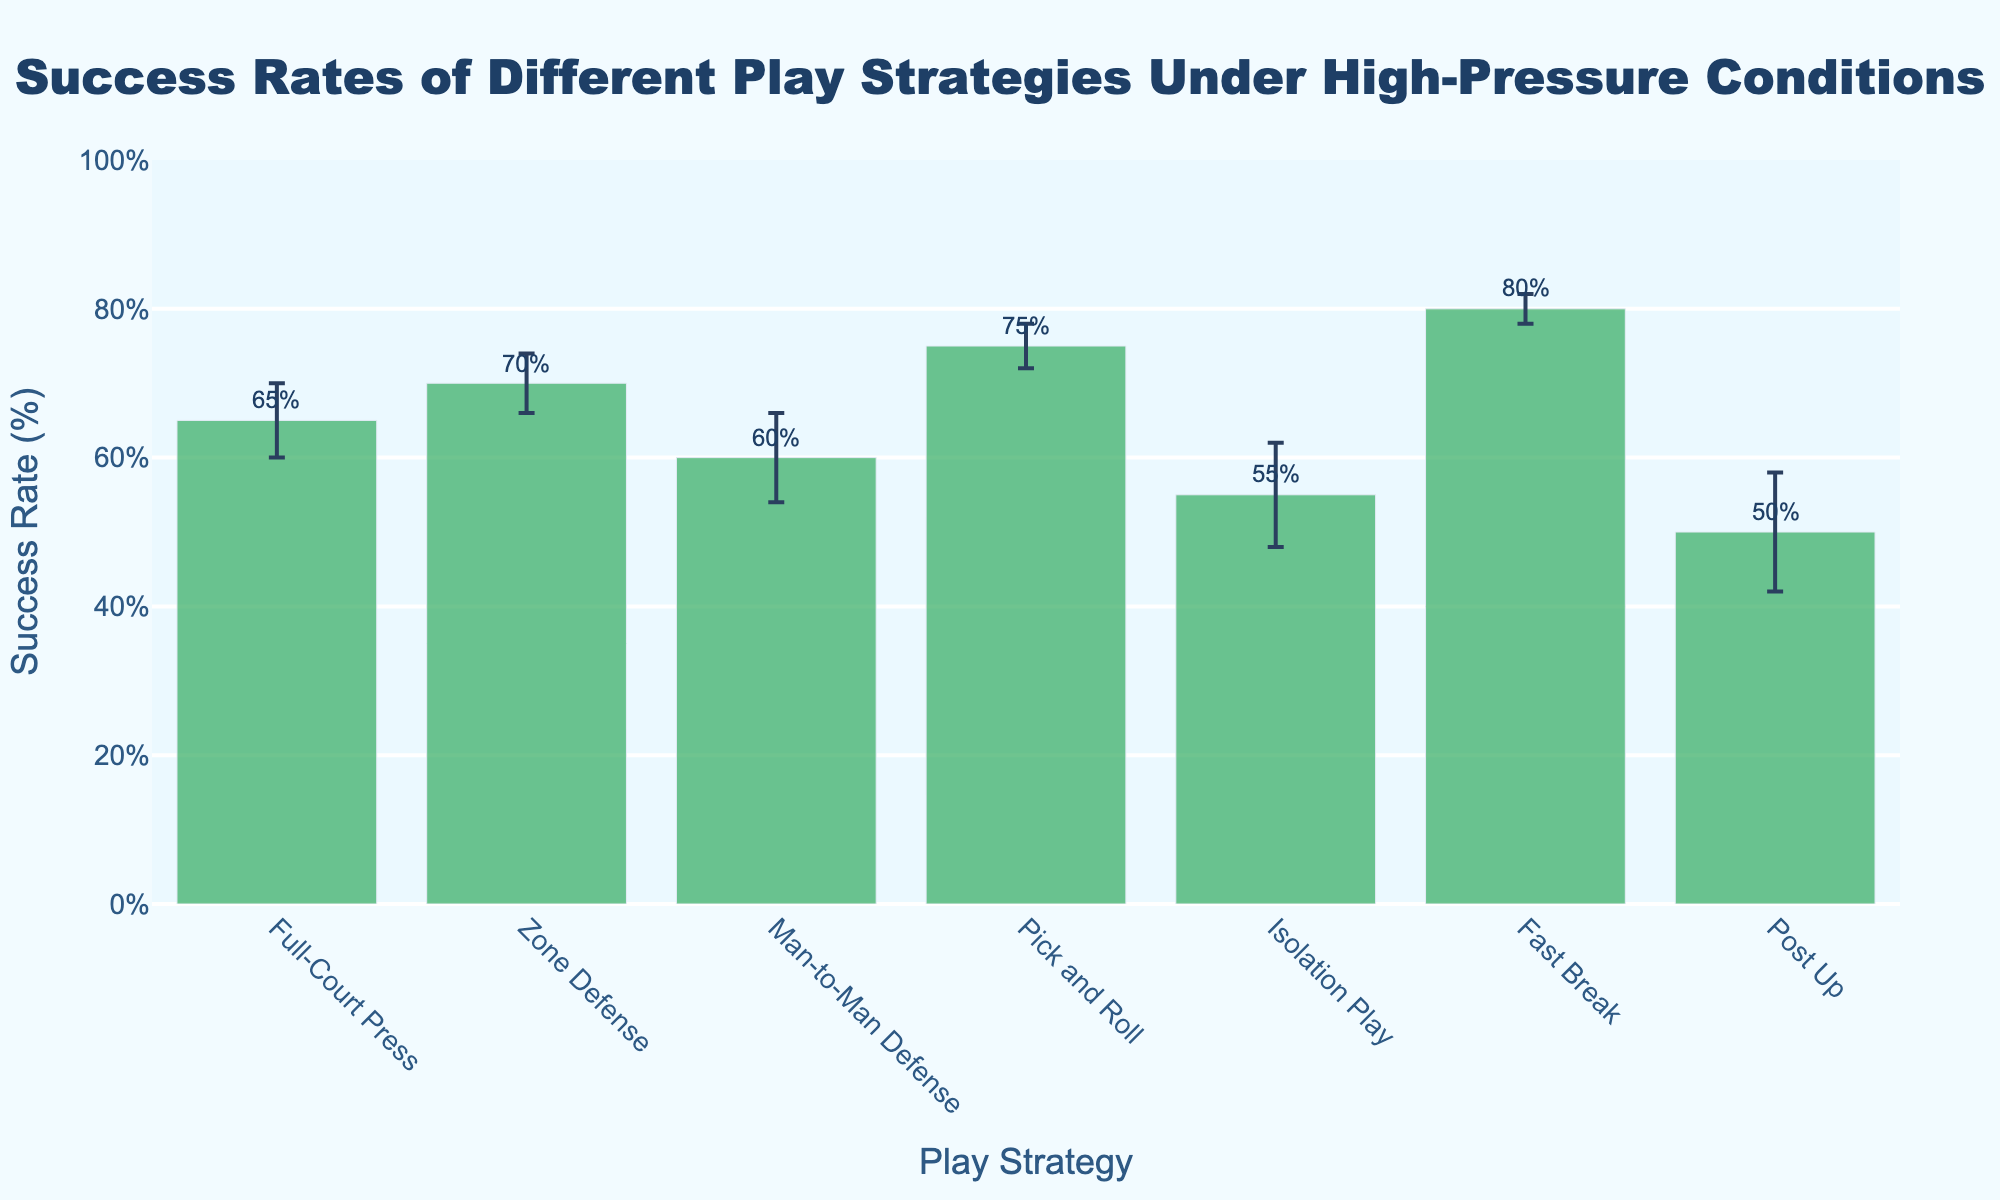what is the title of the figure? The title is a text element that provides an overview or summary of what the chart is about. It is usually displayed at the top of the chart. The figure's title is "Success Rates of Different Play Strategies Under High-Pressure Conditions."
Answer: Success Rates of Different Play Strategies Under High-Pressure Conditions Which play strategy has the highest success rate? To determine the highest success rate, identify the bar that reaches the highest point on the y-axis. The "Fast Break" strategy has the highest success rate at 80%.
Answer: Fast Break What is the success rate for the "Isolation Play" strategy, and how does it compare to the "Pick and Roll" strategy? Locate both "Isolation Play" and "Pick and Roll" on the x-axis, then check their respective bar heights on the y-axis. "Isolation Play" has a success rate of 55%, while "Pick and Roll" has a success rate of 75%. The "Pick and Roll" strategy has a higher success rate by 20%.
Answer: 55%, 75%; Pick and Roll is higher by 20% Which strategy has the largest error margin, and what is its value? Look at the error bars extending above and below each bar. The "Post Up" strategy has the largest error margin of 8.
Answer: Post Up; 8 What is the average success rate of the strategies presented in the figure? Add the success rates of all strategies and divide by the number of strategies. The success rates are 65, 70, 60, 75, 55, 80, and 50. The sum is 455. Divide by 7 to get an average of approximately 65.
Answer: 65 How much more successful is the "Zone Defense" compared to "Full-Court Press"? Find the success rates of "Zone Defense" and "Full-Court Press" from the y-axis. "Zone Defense" has a 70% success rate, and "Full-Court Press" has a 65% success rate. The difference is 5%.
Answer: 5% Between which two strategies is the success rate difference the greatest, and what is the difference? Compare the success rates of all pairs of strategies. The greatest difference is between "Fast Break" (80%) and "Post Up" (50%), which is 30%.
Answer: Fast Break and Post Up; 30% What is the range of success rates among the play strategies? Identify the highest and lowest success rates. The highest is "Fast Break" at 80%, and the lowest is "Post Up" at 50%. The range is 80% - 50% = 30%.
Answer: 30% What are the error margins for "Man-to-Man Defense" and "Pick and Roll"? Error margins are the lengths of the error bars above and below each bar. "Man-to-Man Defense" has an error margin of 6, and "Pick and Roll" has an error margin of 3.
Answer: 6, 3 Are any two strategies' success rates within the same error margin as each other? If so, which ones? Compare the error bars. "Full-Court Press" with 65% ± 5 and "Zone Defense" with 70% ± 4 overlap in the range of their error margins.
Answer: 65% ± 5 and 70% ± 4 overlap; Full-Court Press and Zone Defense 